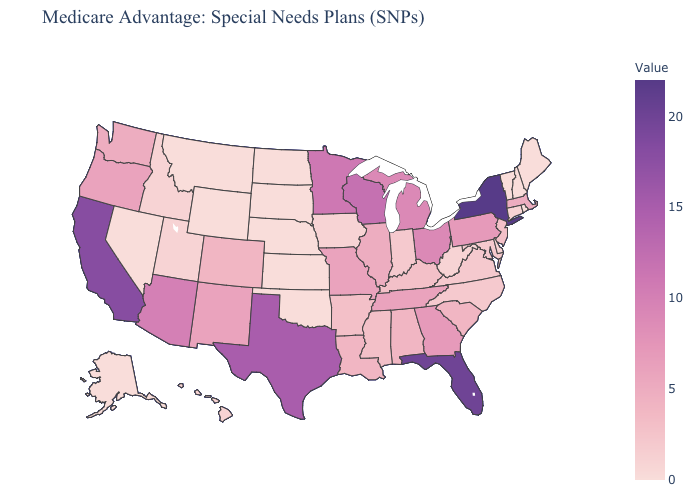Among the states that border Florida , which have the highest value?
Short answer required. Georgia. Does Nebraska have the highest value in the MidWest?
Quick response, please. No. Does Alaska have the highest value in the West?
Answer briefly. No. Does South Dakota have a lower value than Louisiana?
Write a very short answer. Yes. Does Nebraska have the highest value in the USA?
Quick response, please. No. Among the states that border Connecticut , which have the highest value?
Concise answer only. New York. 